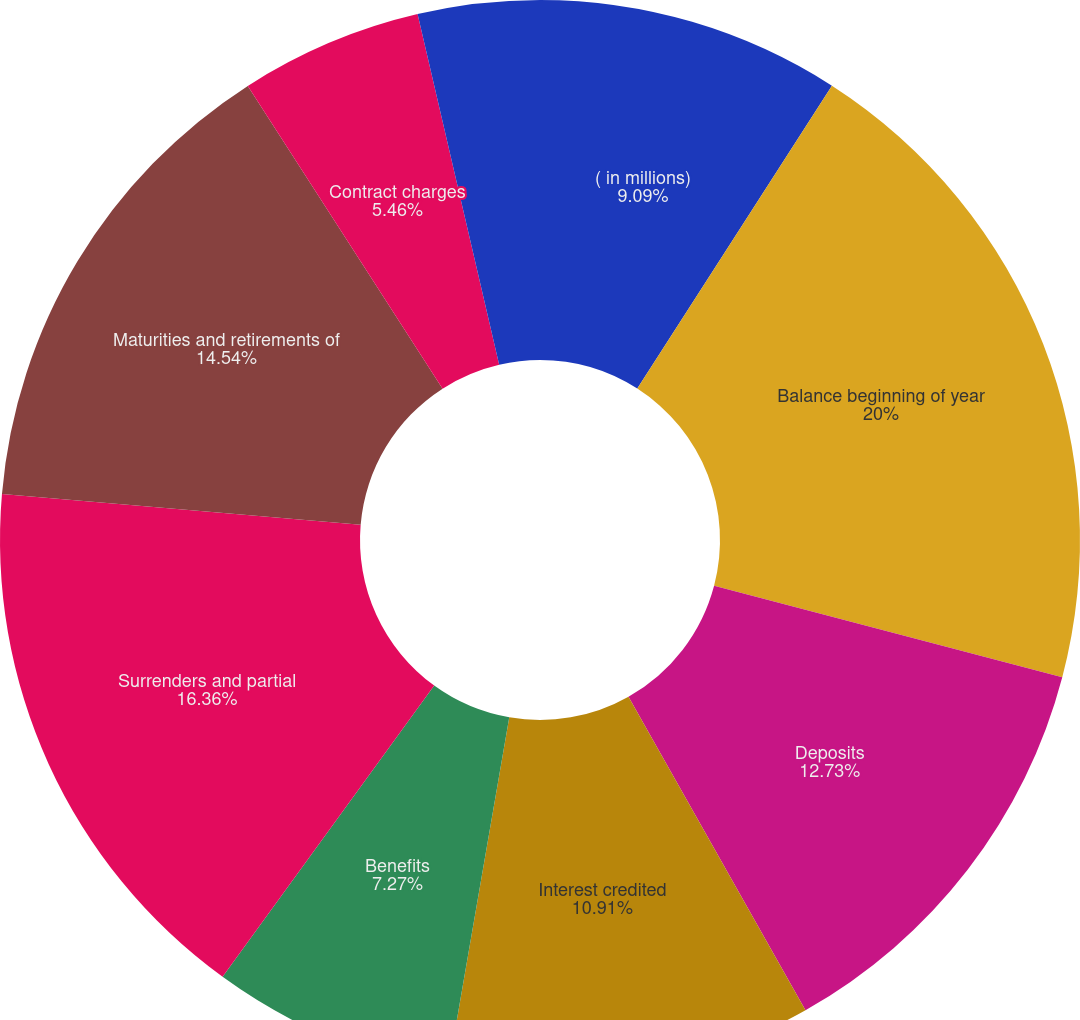Convert chart to OTSL. <chart><loc_0><loc_0><loc_500><loc_500><pie_chart><fcel>( in millions)<fcel>Balance beginning of year<fcel>Deposits<fcel>Interest credited<fcel>Benefits<fcel>Surrenders and partial<fcel>Maturities and retirements of<fcel>Contract charges<fcel>Net transfers from separate<fcel>Fair value hedge adjustments<nl><fcel>9.09%<fcel>20.0%<fcel>12.73%<fcel>10.91%<fcel>7.27%<fcel>16.36%<fcel>14.54%<fcel>5.46%<fcel>0.0%<fcel>3.64%<nl></chart> 